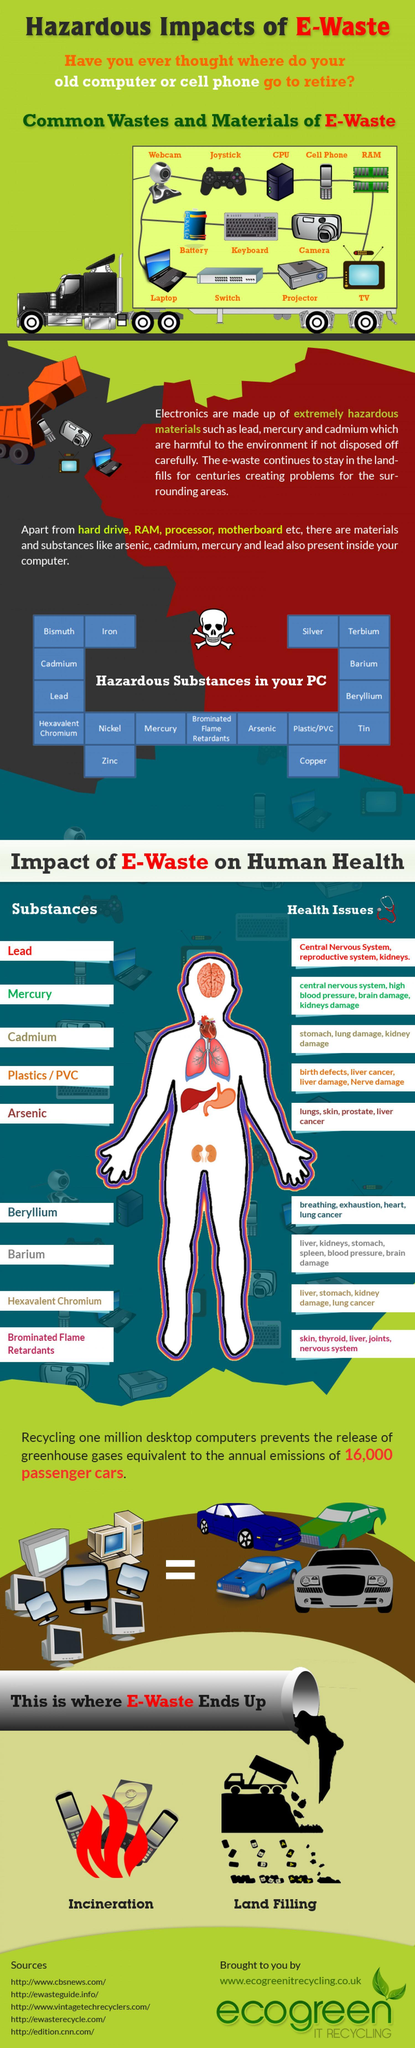what are the substances inside PC that causes liver cancer?
Answer the question with a short phrase. arsenic, plastics/PVC what are the substances inside PC that affect blood pressure? mercury, Barium what are the substances inside PC that causes skin damages? arsenic, brominated flame retardants what are the substances inside PC that causes stomach damage? Cadmium, Barium, hexavalent chromium what are the substances inside PC that causes lung cancer? beryllium, hexavalent chromium how many substances from the chart affect liver? 5 how many dangerous substances in PCs are given in the chart? 17 how many common materials of e-waste are given in the chart? 12 how many substances from the chart affect kidney? 5 how many dangerous substances and their effect on human health are given in this infographic? 9 